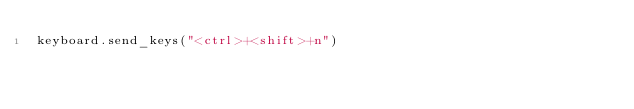<code> <loc_0><loc_0><loc_500><loc_500><_Python_>keyboard.send_keys("<ctrl>+<shift>+n")</code> 